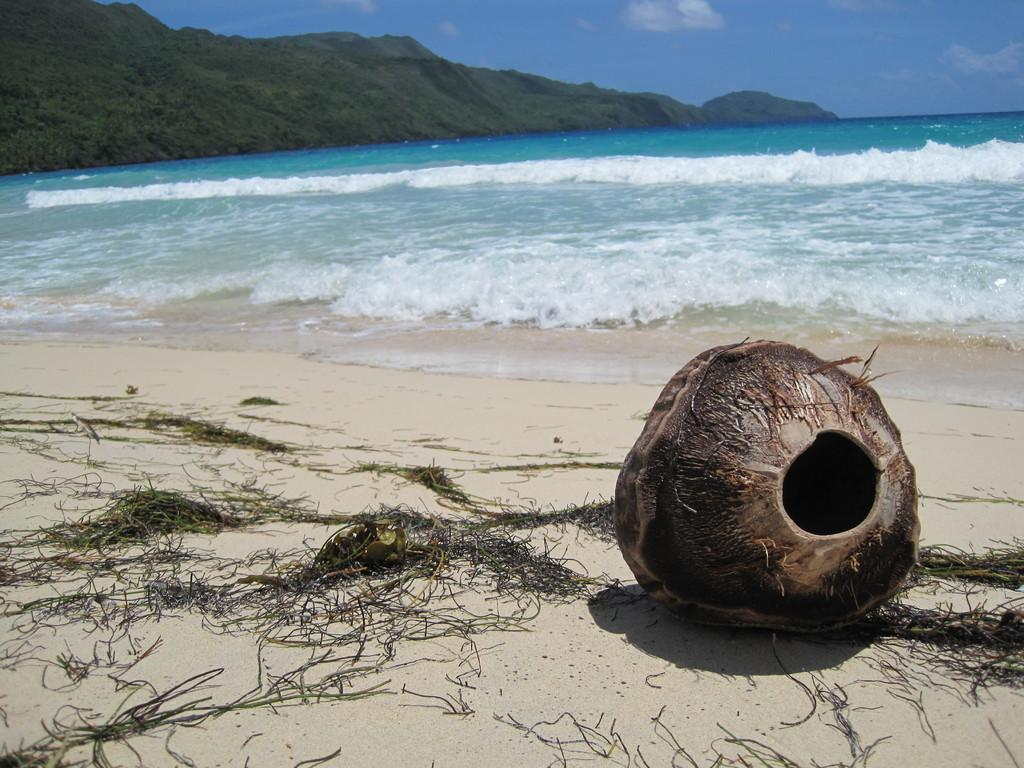What objects can be found on the sand in the image? There are coconuts and twigs on the sand in the image. What can be seen in the water near the sand? There are waves in the water. What is visible in the background of the image? Mountains and the sky are visible in the background. Where is the bubble located in the image? There is no bubble present in the image. Can you describe the frog's behavior in the image? There is no frog present in the image. 